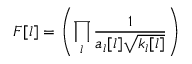<formula> <loc_0><loc_0><loc_500><loc_500>F [ l ] = \left ( \prod _ { l } \frac { 1 } { a _ { l } [ l ] \sqrt { k _ { l } [ l ] } } \right )</formula> 